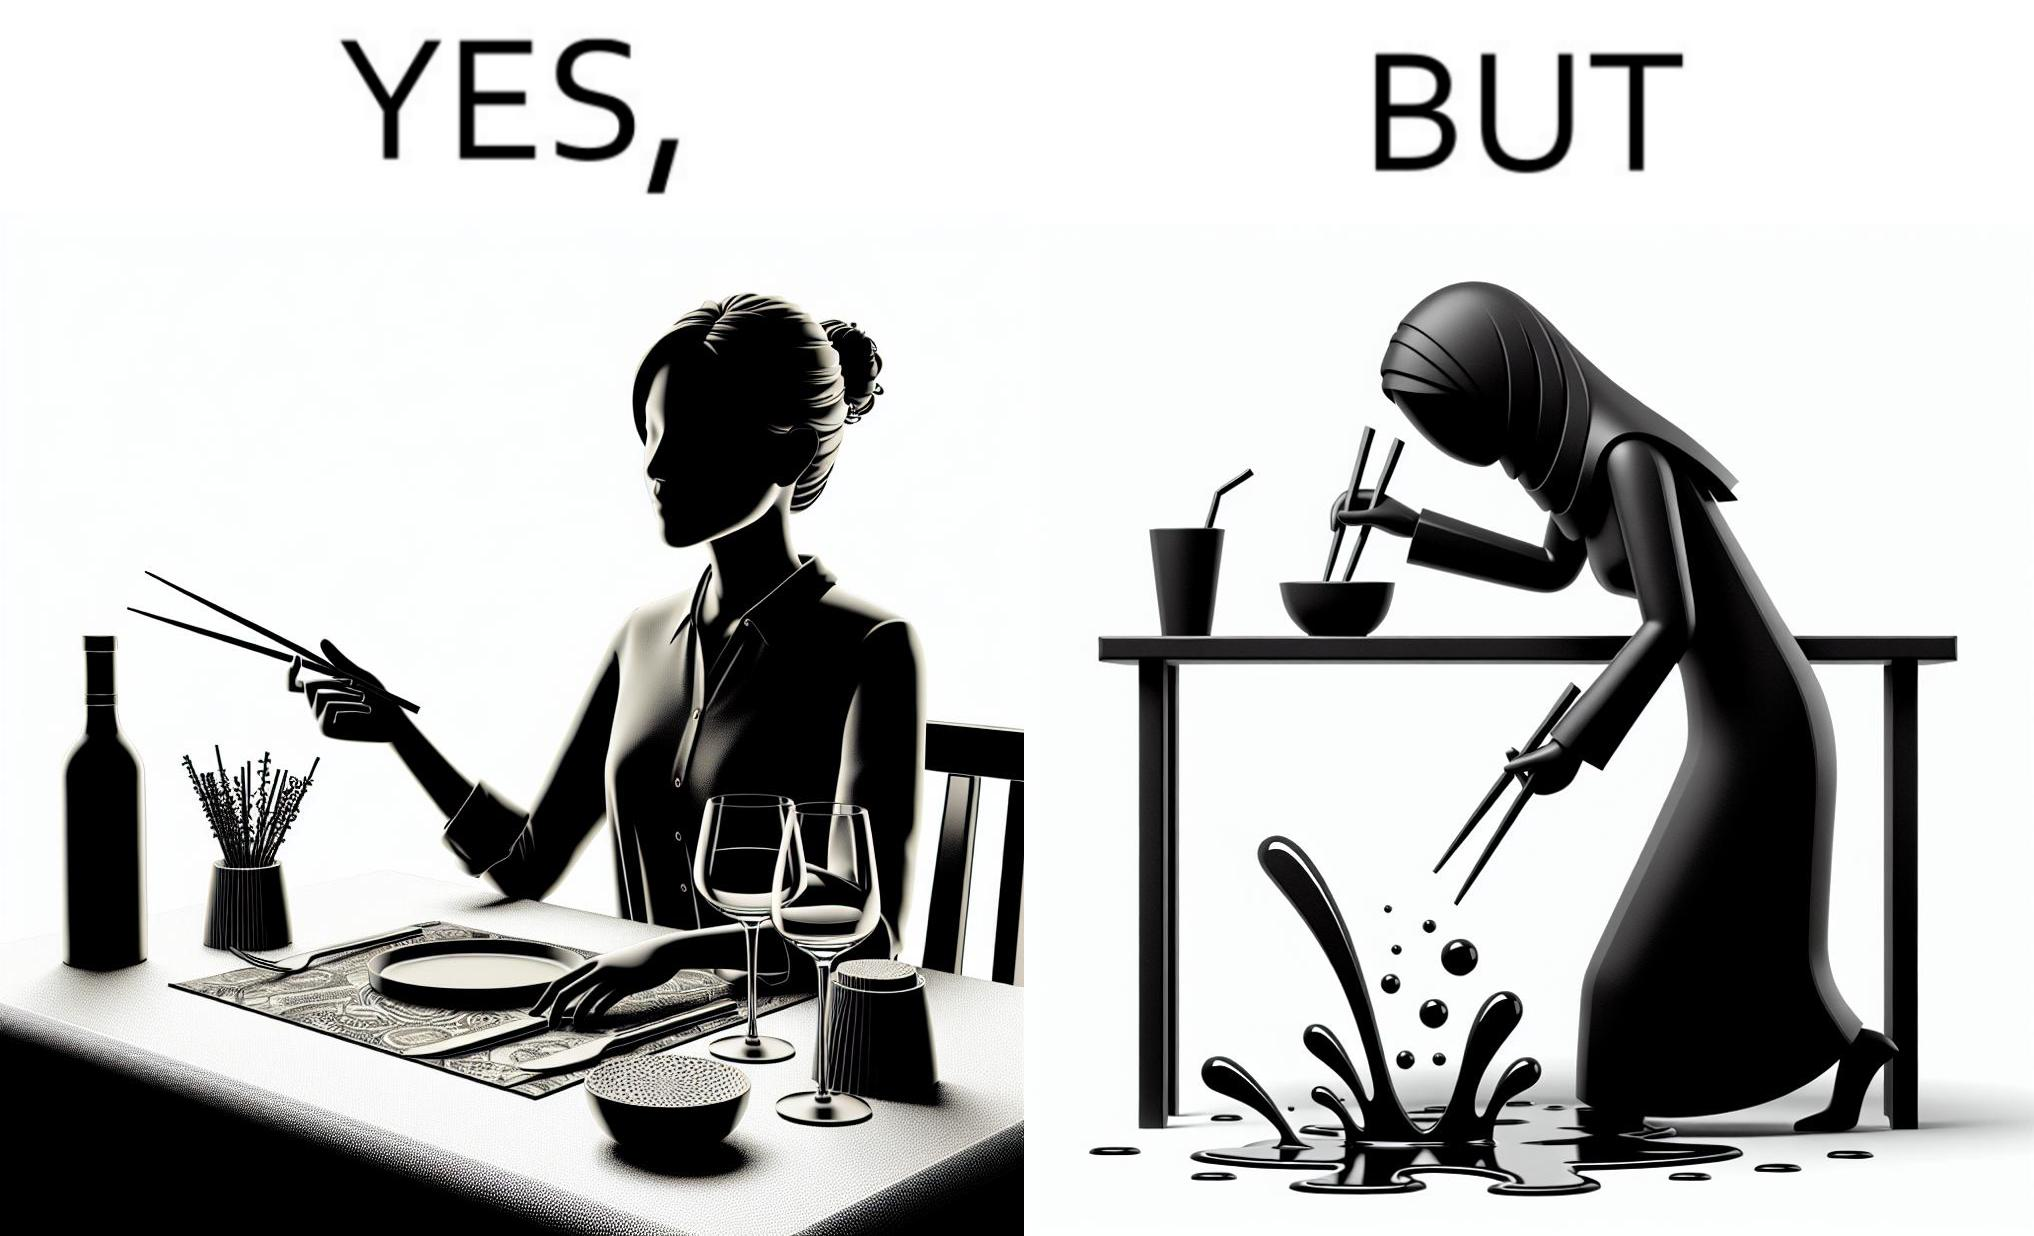Would you classify this image as satirical? Yes, this image is satirical. 